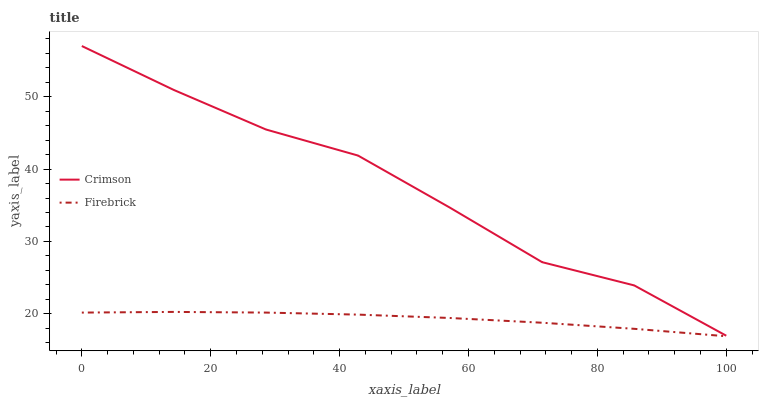Does Firebrick have the maximum area under the curve?
Answer yes or no. No. Is Firebrick the roughest?
Answer yes or no. No. Does Firebrick have the highest value?
Answer yes or no. No. Is Firebrick less than Crimson?
Answer yes or no. Yes. Is Crimson greater than Firebrick?
Answer yes or no. Yes. Does Firebrick intersect Crimson?
Answer yes or no. No. 